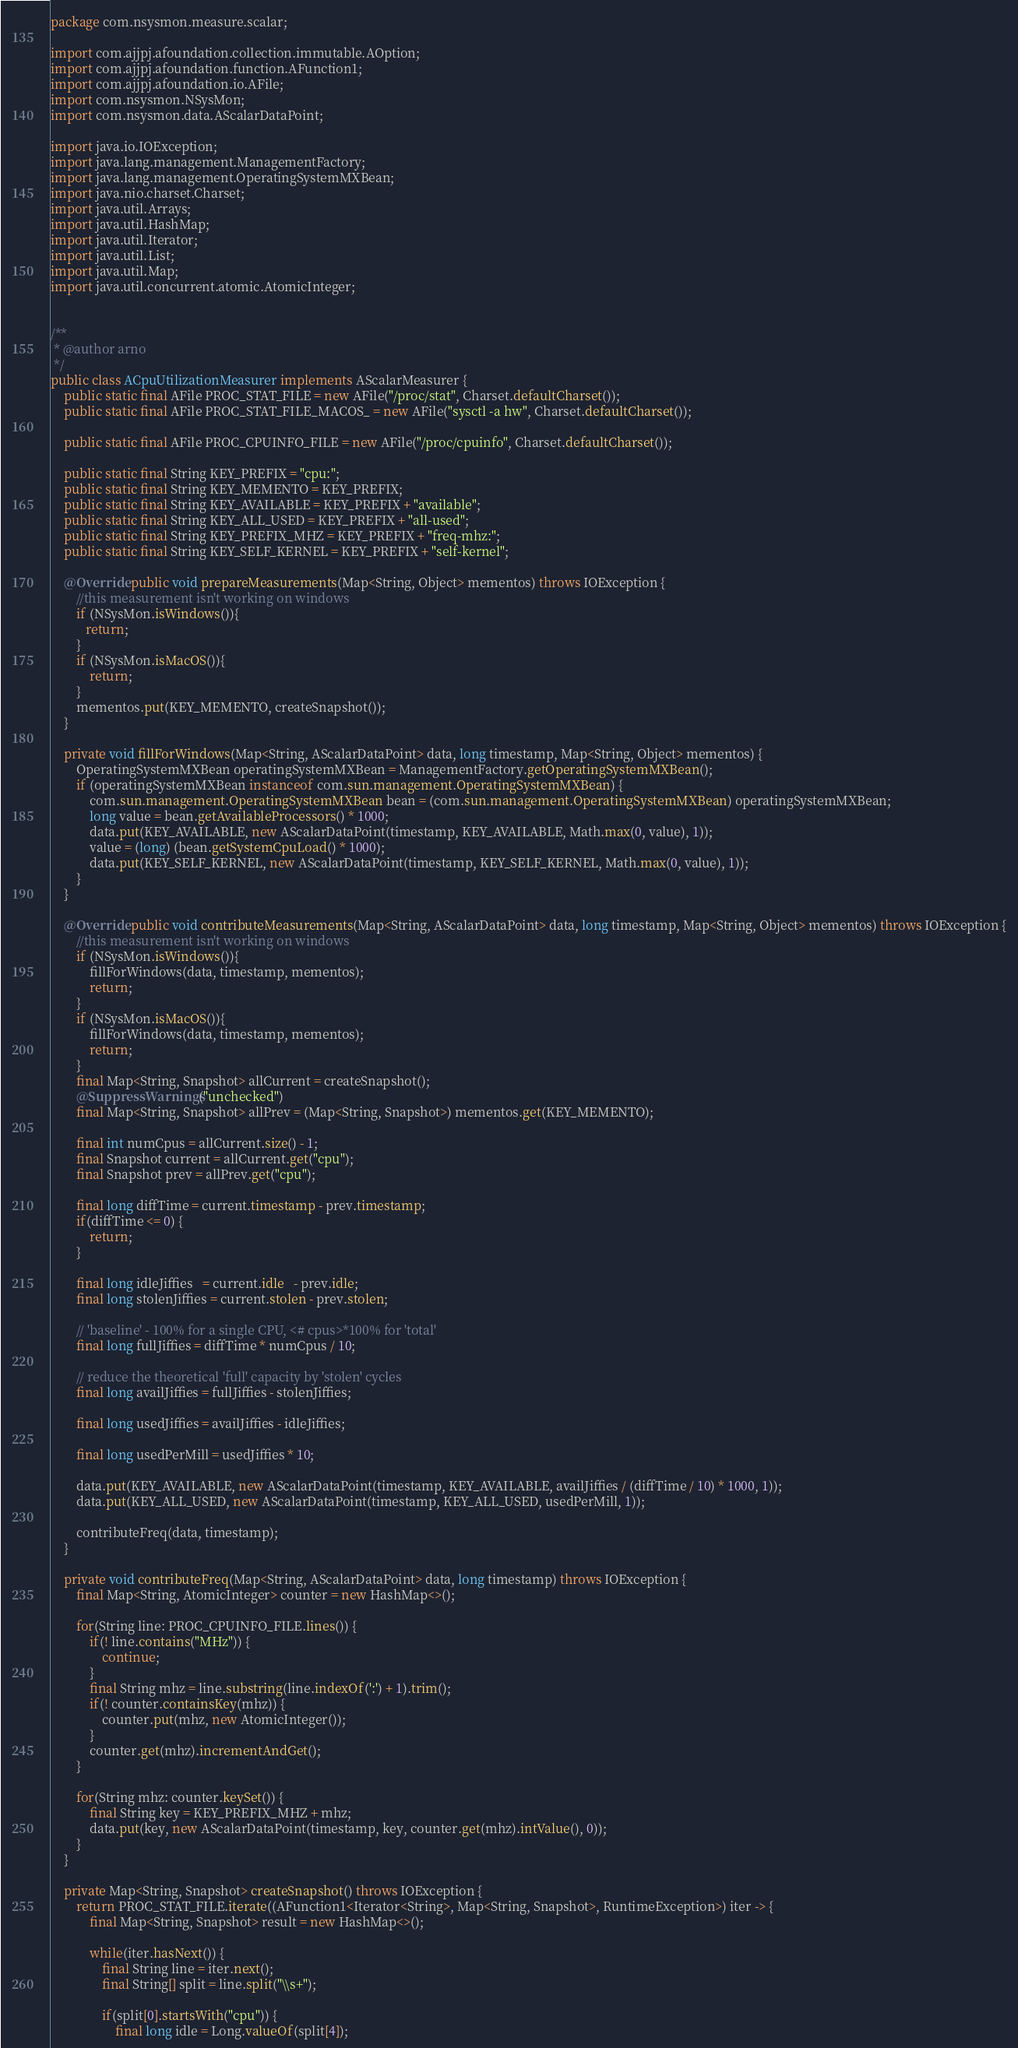<code> <loc_0><loc_0><loc_500><loc_500><_Java_>package com.nsysmon.measure.scalar;

import com.ajjpj.afoundation.collection.immutable.AOption;
import com.ajjpj.afoundation.function.AFunction1;
import com.ajjpj.afoundation.io.AFile;
import com.nsysmon.NSysMon;
import com.nsysmon.data.AScalarDataPoint;

import java.io.IOException;
import java.lang.management.ManagementFactory;
import java.lang.management.OperatingSystemMXBean;
import java.nio.charset.Charset;
import java.util.Arrays;
import java.util.HashMap;
import java.util.Iterator;
import java.util.List;
import java.util.Map;
import java.util.concurrent.atomic.AtomicInteger;


/**
 * @author arno
 */
public class ACpuUtilizationMeasurer implements AScalarMeasurer {
    public static final AFile PROC_STAT_FILE = new AFile("/proc/stat", Charset.defaultCharset());
    public static final AFile PROC_STAT_FILE_MACOS_ = new AFile("sysctl -a hw", Charset.defaultCharset());

    public static final AFile PROC_CPUINFO_FILE = new AFile("/proc/cpuinfo", Charset.defaultCharset());

    public static final String KEY_PREFIX = "cpu:";
    public static final String KEY_MEMENTO = KEY_PREFIX;
    public static final String KEY_AVAILABLE = KEY_PREFIX + "available";
    public static final String KEY_ALL_USED = KEY_PREFIX + "all-used";
    public static final String KEY_PREFIX_MHZ = KEY_PREFIX + "freq-mhz:";
    public static final String KEY_SELF_KERNEL = KEY_PREFIX + "self-kernel";

    @Override public void prepareMeasurements(Map<String, Object> mementos) throws IOException {
        //this measurement isn't working on windows
        if (NSysMon.isWindows()){
           return;
        }
        if (NSysMon.isMacOS()){
            return;
        }
        mementos.put(KEY_MEMENTO, createSnapshot());
    }

    private void fillForWindows(Map<String, AScalarDataPoint> data, long timestamp, Map<String, Object> mementos) {
        OperatingSystemMXBean operatingSystemMXBean = ManagementFactory.getOperatingSystemMXBean();
        if (operatingSystemMXBean instanceof com.sun.management.OperatingSystemMXBean) {
            com.sun.management.OperatingSystemMXBean bean = (com.sun.management.OperatingSystemMXBean) operatingSystemMXBean;
            long value = bean.getAvailableProcessors() * 1000;
            data.put(KEY_AVAILABLE, new AScalarDataPoint(timestamp, KEY_AVAILABLE, Math.max(0, value), 1));
            value = (long) (bean.getSystemCpuLoad() * 1000);
            data.put(KEY_SELF_KERNEL, new AScalarDataPoint(timestamp, KEY_SELF_KERNEL, Math.max(0, value), 1));
        }
    }

    @Override public void contributeMeasurements(Map<String, AScalarDataPoint> data, long timestamp, Map<String, Object> mementos) throws IOException {
        //this measurement isn't working on windows
        if (NSysMon.isWindows()){
            fillForWindows(data, timestamp, mementos);
            return;
        }
        if (NSysMon.isMacOS()){
            fillForWindows(data, timestamp, mementos);
            return;
        }
        final Map<String, Snapshot> allCurrent = createSnapshot();
        @SuppressWarnings("unchecked")
        final Map<String, Snapshot> allPrev = (Map<String, Snapshot>) mementos.get(KEY_MEMENTO);

        final int numCpus = allCurrent.size() - 1;
        final Snapshot current = allCurrent.get("cpu");
        final Snapshot prev = allPrev.get("cpu");

        final long diffTime = current.timestamp - prev.timestamp;
        if(diffTime <= 0) {
            return;
        }

        final long idleJiffies   = current.idle   - prev.idle;
        final long stolenJiffies = current.stolen - prev.stolen;

        // 'baseline' - 100% for a single CPU, <# cpus>*100% for 'total'
        final long fullJiffies = diffTime * numCpus / 10;

        // reduce the theoretical 'full' capacity by 'stolen' cycles
        final long availJiffies = fullJiffies - stolenJiffies;

        final long usedJiffies = availJiffies - idleJiffies;

        final long usedPerMill = usedJiffies * 10;

        data.put(KEY_AVAILABLE, new AScalarDataPoint(timestamp, KEY_AVAILABLE, availJiffies / (diffTime / 10) * 1000, 1));
        data.put(KEY_ALL_USED, new AScalarDataPoint(timestamp, KEY_ALL_USED, usedPerMill, 1));

        contributeFreq(data, timestamp);
    }

    private void contributeFreq(Map<String, AScalarDataPoint> data, long timestamp) throws IOException {
        final Map<String, AtomicInteger> counter = new HashMap<>();

        for(String line: PROC_CPUINFO_FILE.lines()) {
            if(! line.contains("MHz")) {
                continue;
            }
            final String mhz = line.substring(line.indexOf(':') + 1).trim();
            if(! counter.containsKey(mhz)) {
                counter.put(mhz, new AtomicInteger());
            }
            counter.get(mhz).incrementAndGet();
        }

        for(String mhz: counter.keySet()) {
            final String key = KEY_PREFIX_MHZ + mhz;
            data.put(key, new AScalarDataPoint(timestamp, key, counter.get(mhz).intValue(), 0));
        }
    }

    private Map<String, Snapshot> createSnapshot() throws IOException {
        return PROC_STAT_FILE.iterate((AFunction1<Iterator<String>, Map<String, Snapshot>, RuntimeException>) iter -> {
            final Map<String, Snapshot> result = new HashMap<>();

            while(iter.hasNext()) {
                final String line = iter.next();
                final String[] split = line.split("\\s+");

                if(split[0].startsWith("cpu")) {
                    final long idle = Long.valueOf(split[4]);</code> 